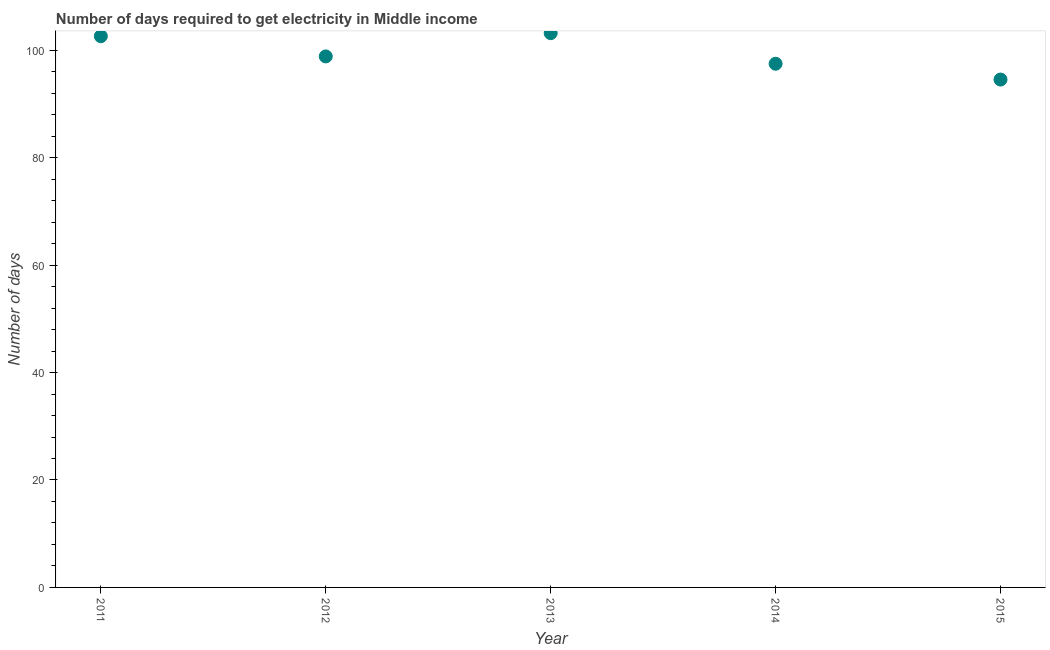What is the time to get electricity in 2013?
Your answer should be very brief. 103.19. Across all years, what is the maximum time to get electricity?
Your answer should be compact. 103.19. Across all years, what is the minimum time to get electricity?
Your answer should be compact. 94.55. In which year was the time to get electricity minimum?
Give a very brief answer. 2015. What is the sum of the time to get electricity?
Keep it short and to the point. 496.71. What is the difference between the time to get electricity in 2012 and 2014?
Offer a very short reply. 1.37. What is the average time to get electricity per year?
Ensure brevity in your answer.  99.34. What is the median time to get electricity?
Keep it short and to the point. 98.86. Do a majority of the years between 2012 and 2011 (inclusive) have time to get electricity greater than 44 ?
Ensure brevity in your answer.  No. What is the ratio of the time to get electricity in 2012 to that in 2015?
Offer a terse response. 1.05. Is the time to get electricity in 2012 less than that in 2013?
Your answer should be very brief. Yes. Is the difference between the time to get electricity in 2011 and 2015 greater than the difference between any two years?
Offer a very short reply. No. What is the difference between the highest and the second highest time to get electricity?
Your response must be concise. 0.57. Is the sum of the time to get electricity in 2012 and 2014 greater than the maximum time to get electricity across all years?
Offer a very short reply. Yes. What is the difference between the highest and the lowest time to get electricity?
Keep it short and to the point. 8.64. In how many years, is the time to get electricity greater than the average time to get electricity taken over all years?
Provide a short and direct response. 2. How many dotlines are there?
Ensure brevity in your answer.  1. How many years are there in the graph?
Your answer should be compact. 5. Are the values on the major ticks of Y-axis written in scientific E-notation?
Your response must be concise. No. Does the graph contain any zero values?
Offer a very short reply. No. Does the graph contain grids?
Offer a terse response. No. What is the title of the graph?
Your answer should be compact. Number of days required to get electricity in Middle income. What is the label or title of the X-axis?
Provide a short and direct response. Year. What is the label or title of the Y-axis?
Your answer should be compact. Number of days. What is the Number of days in 2011?
Provide a succinct answer. 102.62. What is the Number of days in 2012?
Your answer should be very brief. 98.86. What is the Number of days in 2013?
Offer a very short reply. 103.19. What is the Number of days in 2014?
Your response must be concise. 97.49. What is the Number of days in 2015?
Offer a terse response. 94.55. What is the difference between the Number of days in 2011 and 2012?
Offer a terse response. 3.76. What is the difference between the Number of days in 2011 and 2013?
Your answer should be very brief. -0.57. What is the difference between the Number of days in 2011 and 2014?
Ensure brevity in your answer.  5.13. What is the difference between the Number of days in 2011 and 2015?
Ensure brevity in your answer.  8.07. What is the difference between the Number of days in 2012 and 2013?
Offer a very short reply. -4.33. What is the difference between the Number of days in 2012 and 2014?
Your response must be concise. 1.37. What is the difference between the Number of days in 2012 and 2015?
Offer a very short reply. 4.31. What is the difference between the Number of days in 2013 and 2014?
Offer a very short reply. 5.7. What is the difference between the Number of days in 2013 and 2015?
Offer a terse response. 8.64. What is the difference between the Number of days in 2014 and 2015?
Provide a succinct answer. 2.94. What is the ratio of the Number of days in 2011 to that in 2012?
Your answer should be compact. 1.04. What is the ratio of the Number of days in 2011 to that in 2014?
Give a very brief answer. 1.05. What is the ratio of the Number of days in 2011 to that in 2015?
Keep it short and to the point. 1.08. What is the ratio of the Number of days in 2012 to that in 2013?
Give a very brief answer. 0.96. What is the ratio of the Number of days in 2012 to that in 2015?
Provide a succinct answer. 1.05. What is the ratio of the Number of days in 2013 to that in 2014?
Ensure brevity in your answer.  1.06. What is the ratio of the Number of days in 2013 to that in 2015?
Your response must be concise. 1.09. What is the ratio of the Number of days in 2014 to that in 2015?
Give a very brief answer. 1.03. 